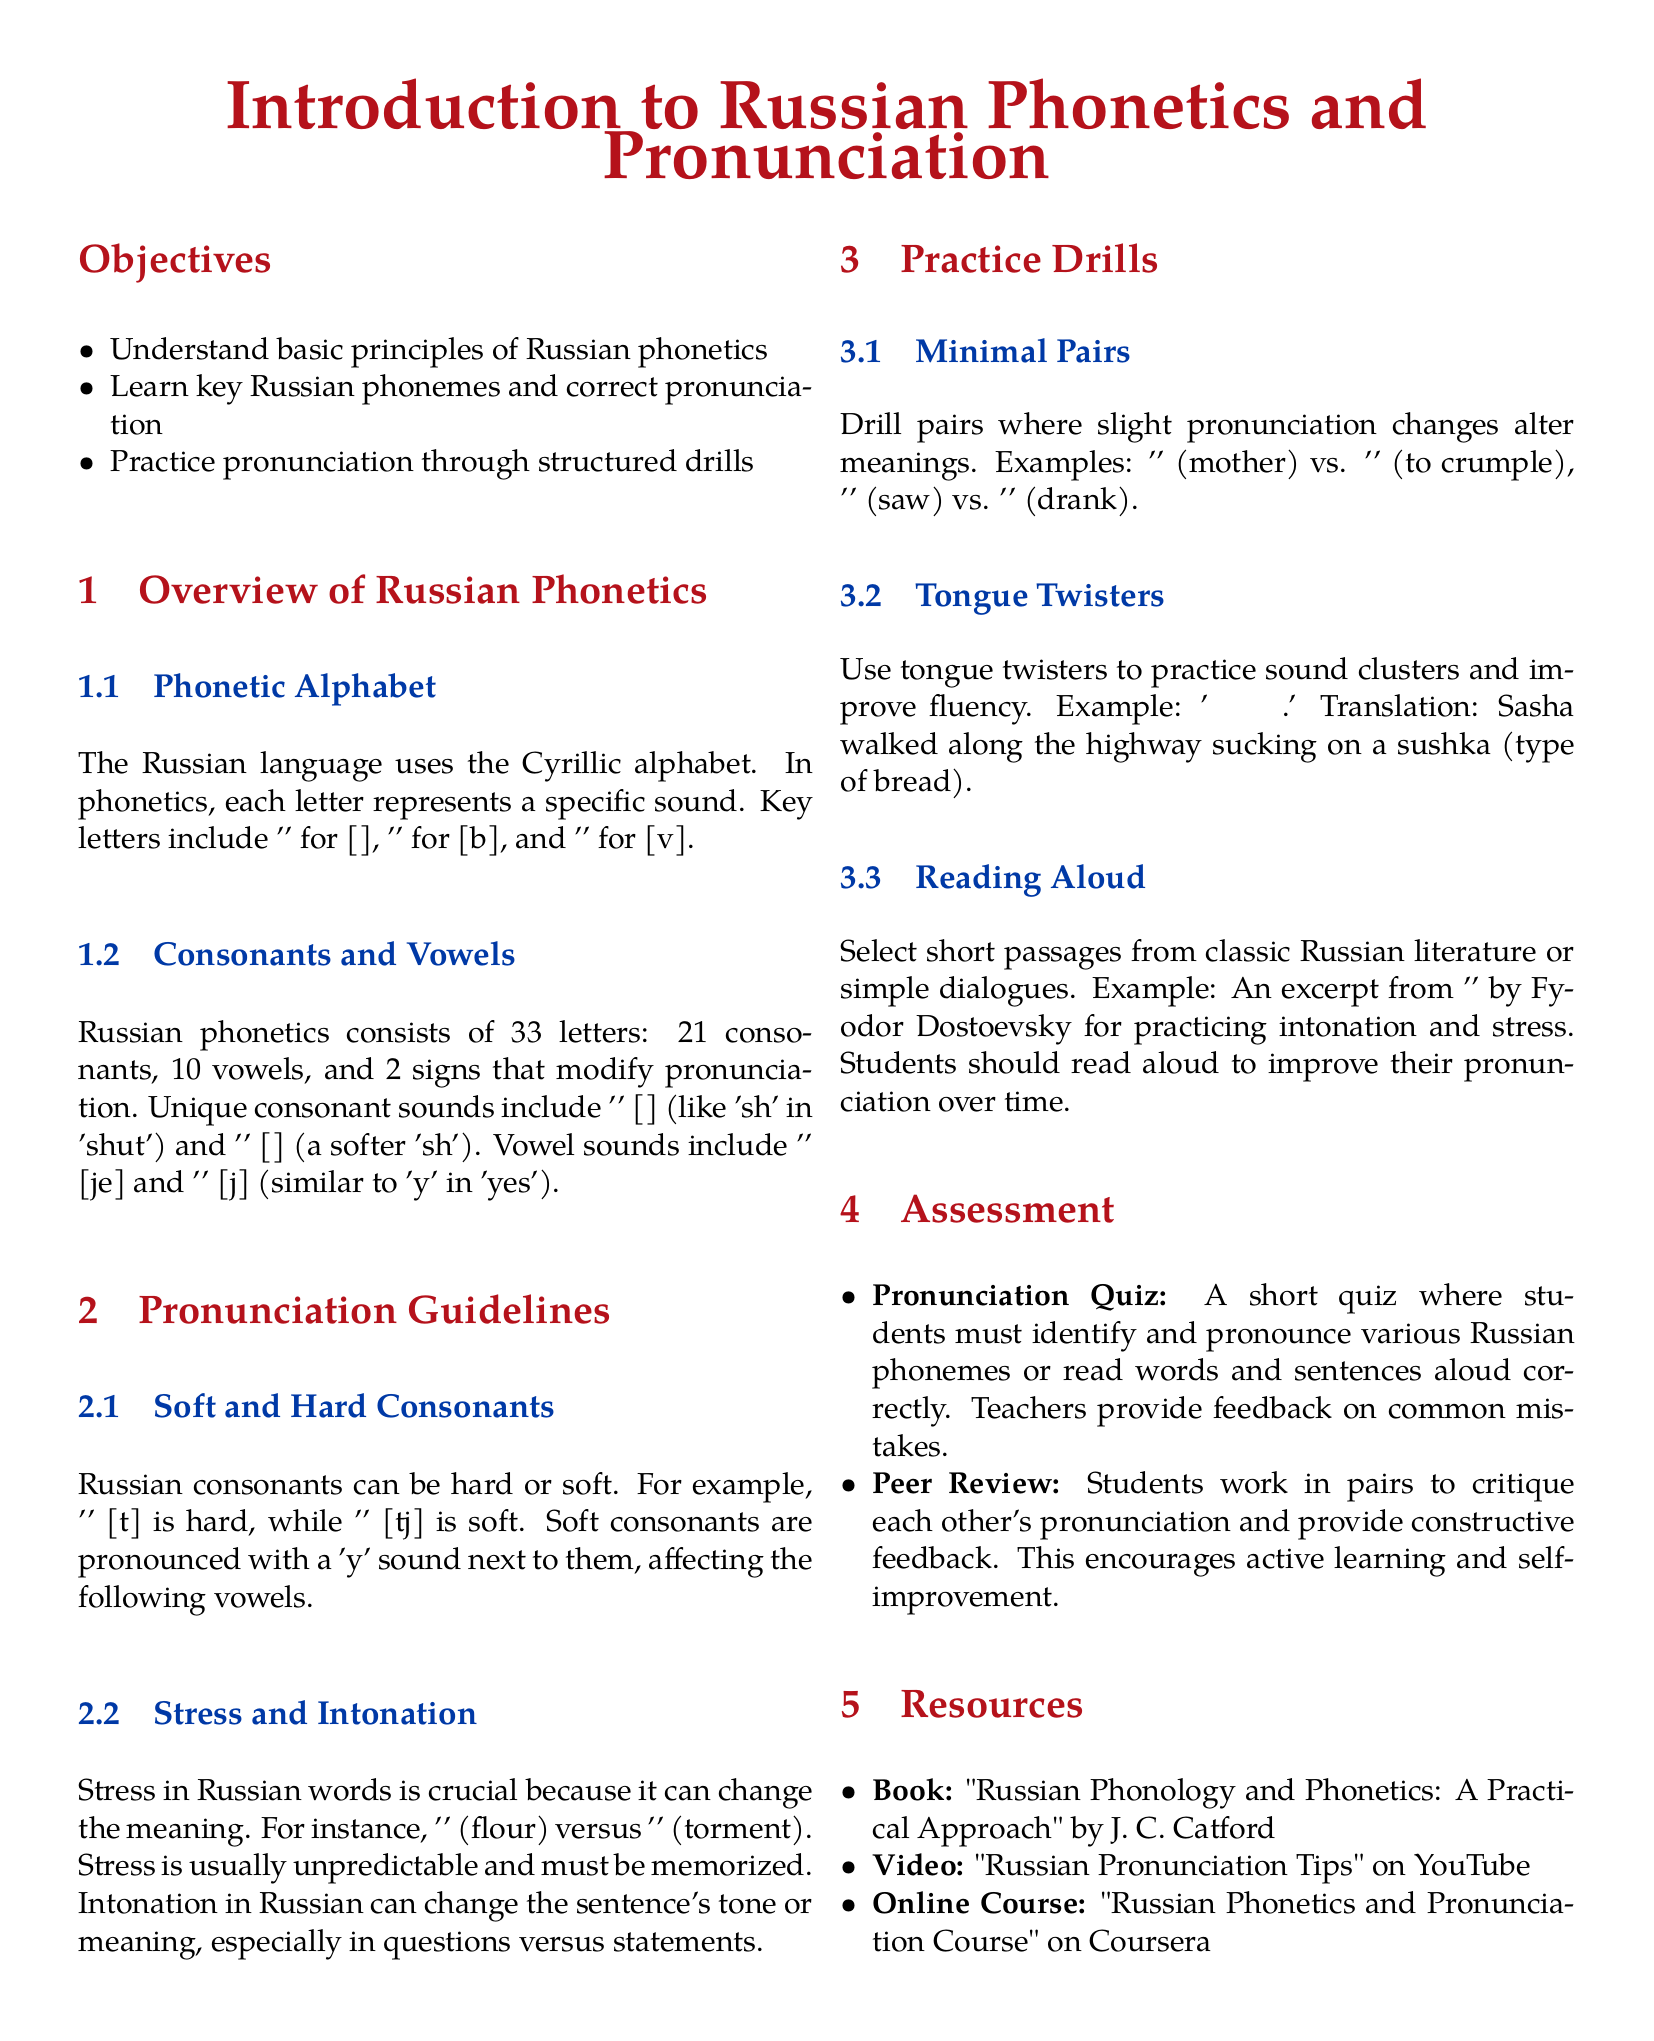What is the title of the lesson? The title of the lesson is the main heading at the top of the document, summarizing the content.
Answer: Introduction to Russian Phonetics and Pronunciation How many consonants are in the Russian phonetic alphabet? The number of consonants in the Russian phonetic alphabet is mentioned in the overview section of the document.
Answer: 21 What is the first exercise type listed in the practice drills? The first exercise type is described under the Practice Drills section.
Answer: Minimal Pairs What distinguishes hard and soft consonants in Russian? The explanation about hard and soft consonants can be found in the Pronunciation Guidelines section.
Answer: A 'y' sound next to soft consonants What is the recommended resource for further learning? The resources section lists various materials for enhancing knowledge of Russian phonetics and pronunciation.
Answer: "Russian Phonology and Phonetics: A Practical Approach" What is an example of a tongue twister included in the lesson plan? The example is provided in the Practice Drills section under the tongue twisters subheading.
Answer: "Шла Саша по шоссе и сосала сушку." What type of feedback is expected during the peer review? The assessment section highlights the nature of feedback to be provided during the peer review process.
Answer: Constructive feedback What are students assessed on during the pronunciation quiz? The assessment section states the focus of the pronunciation quiz regarding student performance.
Answer: Identifying and pronouncing various Russian phonemes 